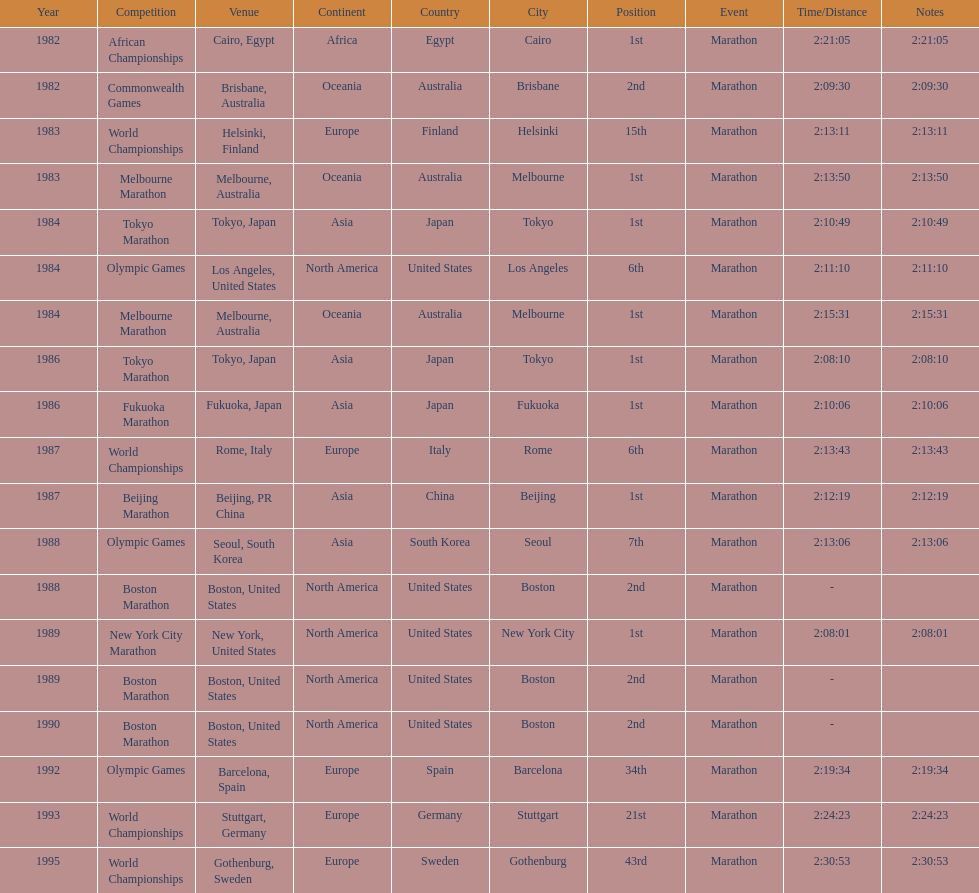How many times in total did ikangaa run the marathon in the olympic games? 3. 